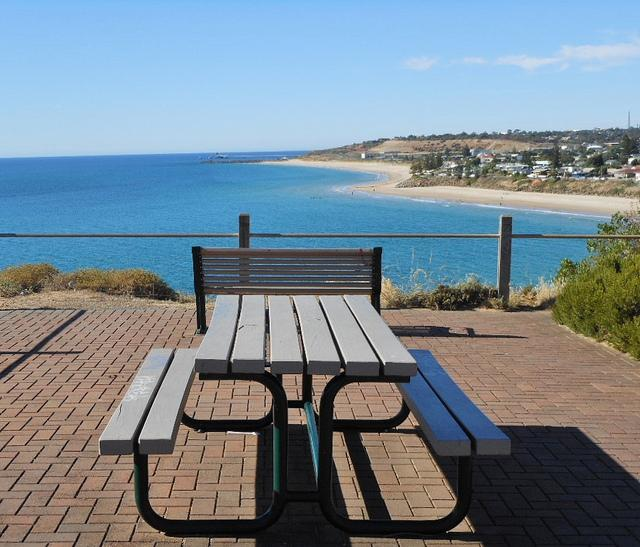What color is the top of the picnic bench painted all up like?

Choices:
A) yellow
B) blue
C) red
D) gray gray 